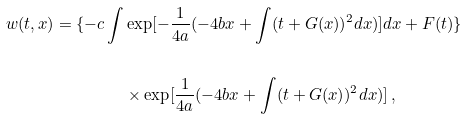Convert formula to latex. <formula><loc_0><loc_0><loc_500><loc_500>w ( t , x ) = \{ - c \int & \exp [ - \frac { 1 } { 4 a } ( - 4 b x + \int ( t + G ( x ) ) ^ { 2 } d x ) ] d x + F ( t ) \} \\ \\ & \times \exp [ \frac { 1 } { 4 a } ( - 4 b x + \int ( t + G ( x ) ) ^ { 2 } d x ) ] \, ,</formula> 